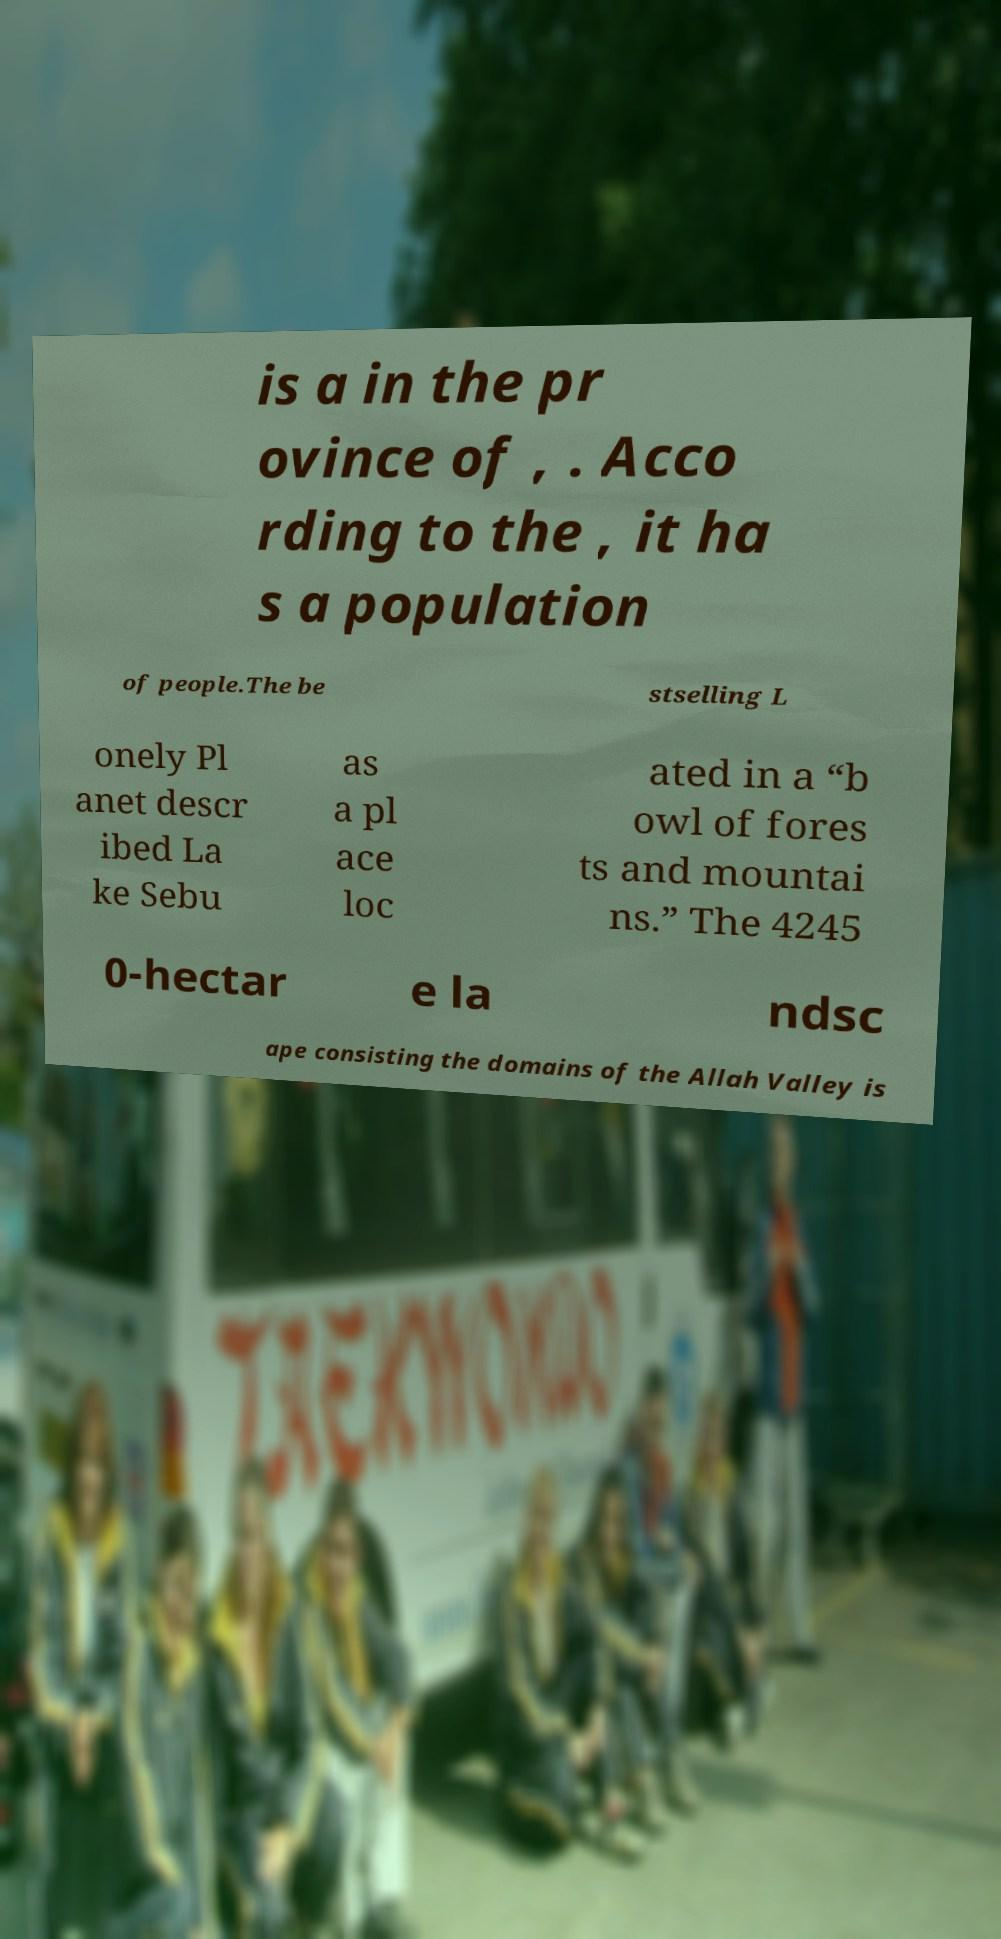I need the written content from this picture converted into text. Can you do that? is a in the pr ovince of , . Acco rding to the , it ha s a population of people.The be stselling L onely Pl anet descr ibed La ke Sebu as a pl ace loc ated in a “b owl of fores ts and mountai ns.” The 4245 0-hectar e la ndsc ape consisting the domains of the Allah Valley is 